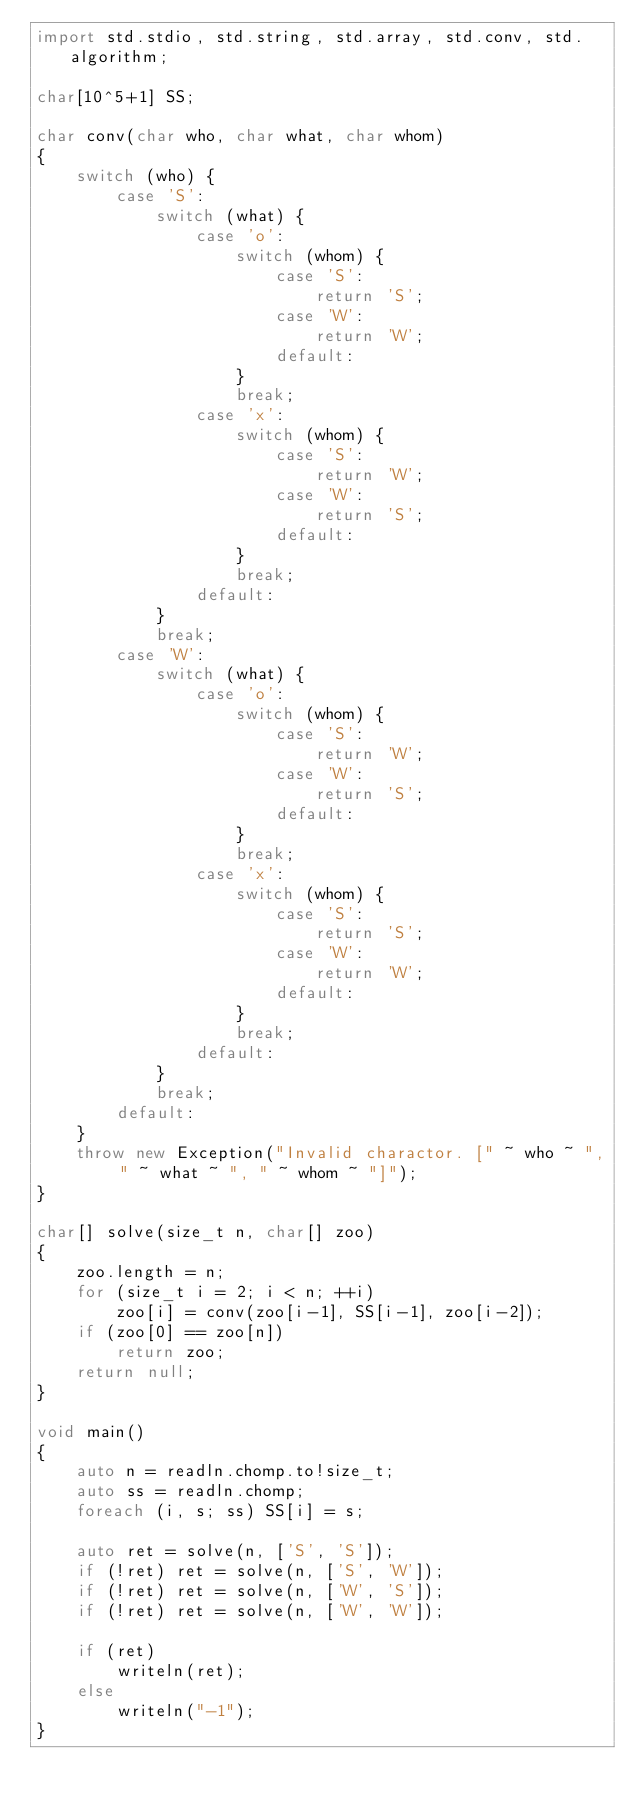Convert code to text. <code><loc_0><loc_0><loc_500><loc_500><_D_>import std.stdio, std.string, std.array, std.conv, std.algorithm;

char[10^5+1] SS;

char conv(char who, char what, char whom)
{
    switch (who) {
        case 'S':
            switch (what) {
                case 'o':
                    switch (whom) {
                        case 'S':
                            return 'S';
                        case 'W':
                            return 'W';
                        default:
                    }
                    break;
                case 'x':
                    switch (whom) {
                        case 'S':
                            return 'W';
                        case 'W':
                            return 'S';
                        default:
                    }
                    break;
                default:
            }
            break;
        case 'W':
            switch (what) {
                case 'o':
                    switch (whom) {
                        case 'S':
                            return 'W';
                        case 'W':
                            return 'S';
                        default:
                    }
                    break;
                case 'x':
                    switch (whom) {
                        case 'S':
                            return 'S';
                        case 'W':
                            return 'W';
                        default:
                    }
                    break;
                default:
            }
            break;
        default:
    }
    throw new Exception("Invalid charactor. [" ~ who ~ ", " ~ what ~ ", " ~ whom ~ "]");
}

char[] solve(size_t n, char[] zoo)
{
    zoo.length = n;
    for (size_t i = 2; i < n; ++i)
        zoo[i] = conv(zoo[i-1], SS[i-1], zoo[i-2]);
    if (zoo[0] == zoo[n])
        return zoo;
    return null;
}

void main()
{
    auto n = readln.chomp.to!size_t;
    auto ss = readln.chomp;
    foreach (i, s; ss) SS[i] = s;
    
    auto ret = solve(n, ['S', 'S']);
    if (!ret) ret = solve(n, ['S', 'W']);
    if (!ret) ret = solve(n, ['W', 'S']);
    if (!ret) ret = solve(n, ['W', 'W']);
    
    if (ret)
        writeln(ret);
    else
        writeln("-1");
}</code> 